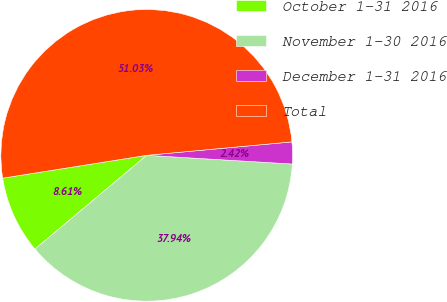<chart> <loc_0><loc_0><loc_500><loc_500><pie_chart><fcel>October 1-31 2016<fcel>November 1-30 2016<fcel>December 1-31 2016<fcel>Total<nl><fcel>8.61%<fcel>37.94%<fcel>2.42%<fcel>51.03%<nl></chart> 